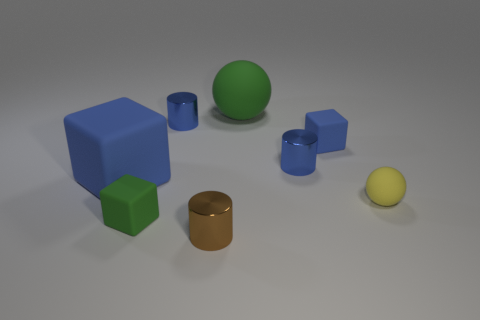How many other objects are the same color as the large rubber cube?
Give a very brief answer. 3. What number of other objects are the same material as the small blue cube?
Provide a short and direct response. 4. There is another object that is the same shape as the yellow matte object; what is its size?
Offer a terse response. Large. What material is the cylinder in front of the blue matte thing to the left of the rubber block that is to the right of the big green matte object?
Give a very brief answer. Metal. Is there a small green matte cylinder?
Ensure brevity in your answer.  No. Do the big matte sphere and the small matte block left of the big ball have the same color?
Make the answer very short. Yes. What color is the small sphere?
Provide a succinct answer. Yellow. What color is the big rubber thing that is the same shape as the tiny green matte object?
Your response must be concise. Blue. Do the yellow rubber object and the big green matte object have the same shape?
Offer a very short reply. Yes. How many cubes are small blue objects or brown objects?
Ensure brevity in your answer.  1. 